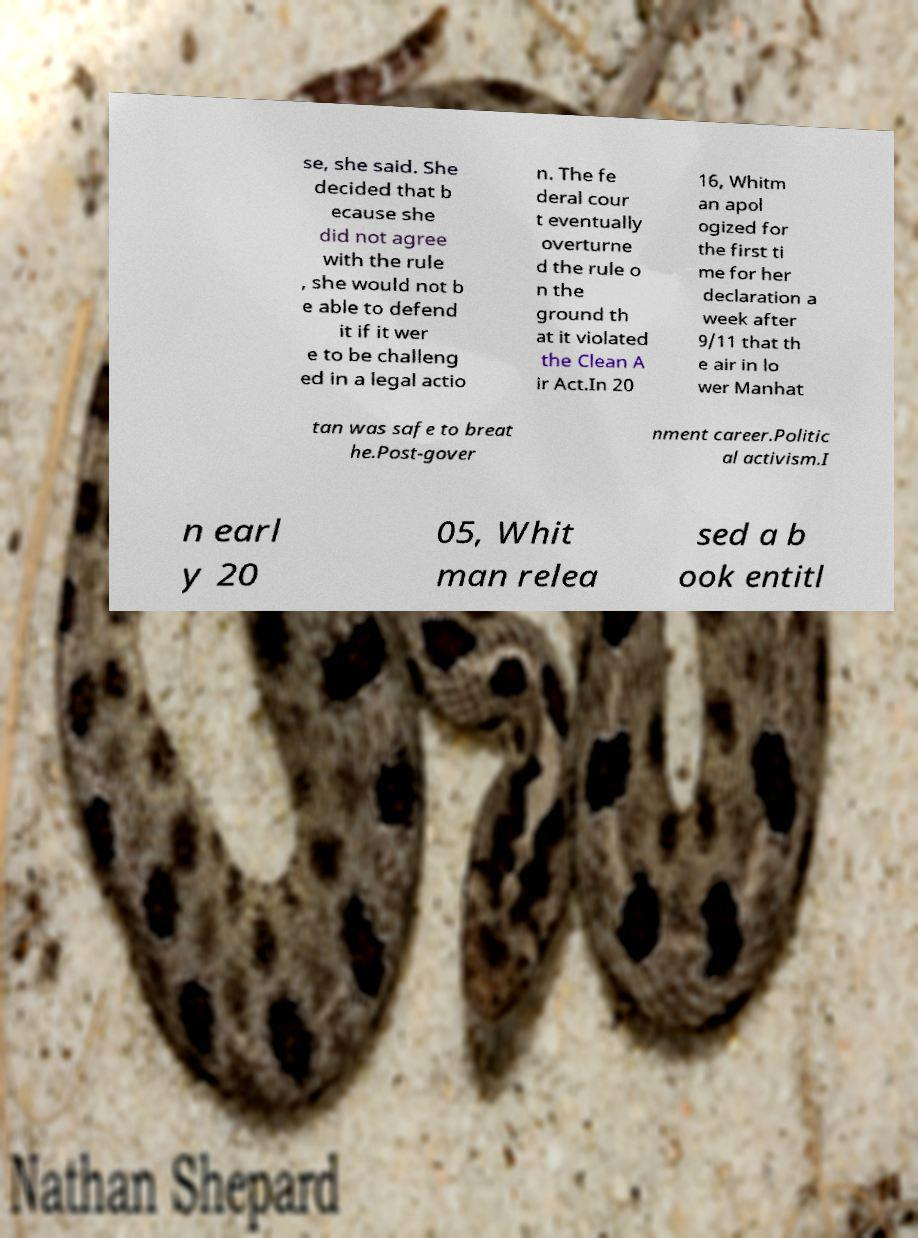Please read and relay the text visible in this image. What does it say? se, she said. She decided that b ecause she did not agree with the rule , she would not b e able to defend it if it wer e to be challeng ed in a legal actio n. The fe deral cour t eventually overturne d the rule o n the ground th at it violated the Clean A ir Act.In 20 16, Whitm an apol ogized for the first ti me for her declaration a week after 9/11 that th e air in lo wer Manhat tan was safe to breat he.Post-gover nment career.Politic al activism.I n earl y 20 05, Whit man relea sed a b ook entitl 